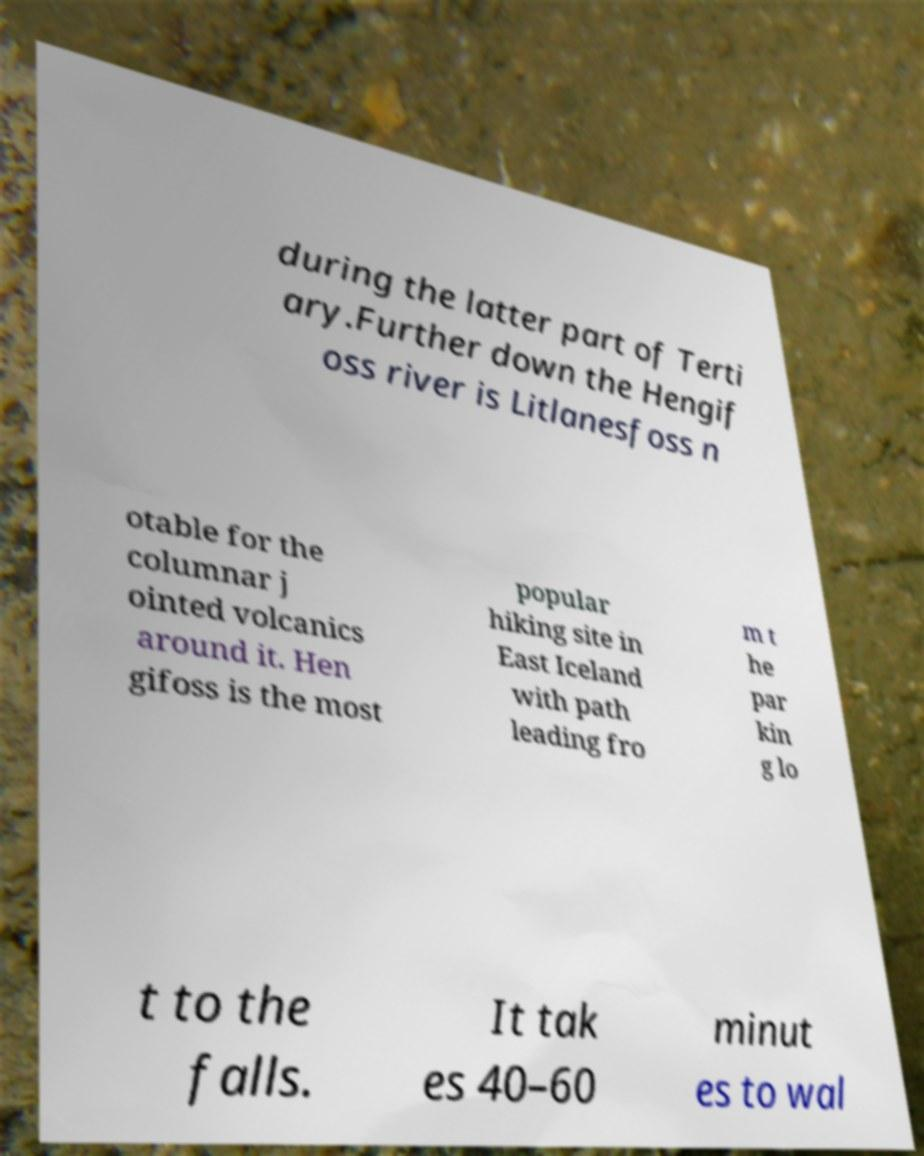Please identify and transcribe the text found in this image. during the latter part of Terti ary.Further down the Hengif oss river is Litlanesfoss n otable for the columnar j ointed volcanics around it. Hen gifoss is the most popular hiking site in East Iceland with path leading fro m t he par kin g lo t to the falls. It tak es 40–60 minut es to wal 